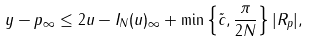<formula> <loc_0><loc_0><loc_500><loc_500>\| y - p \| _ { \infty } \leq 2 \| u - I _ { N } ( u ) \| _ { \infty } + \min \left \{ \tilde { c } , \frac { \pi } { 2 N } \right \} | R _ { p } | ,</formula> 